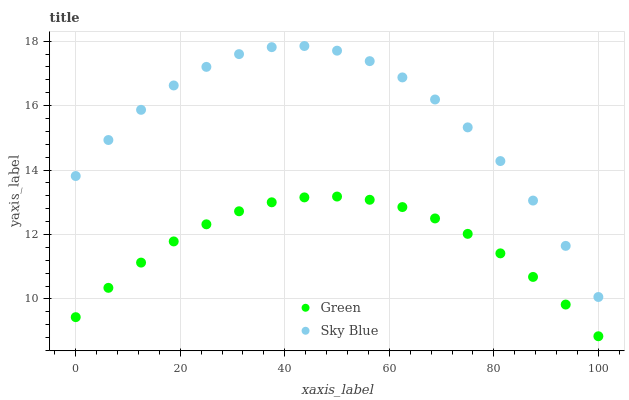Does Green have the minimum area under the curve?
Answer yes or no. Yes. Does Sky Blue have the maximum area under the curve?
Answer yes or no. Yes. Does Green have the maximum area under the curve?
Answer yes or no. No. Is Green the smoothest?
Answer yes or no. Yes. Is Sky Blue the roughest?
Answer yes or no. Yes. Is Green the roughest?
Answer yes or no. No. Does Green have the lowest value?
Answer yes or no. Yes. Does Sky Blue have the highest value?
Answer yes or no. Yes. Does Green have the highest value?
Answer yes or no. No. Is Green less than Sky Blue?
Answer yes or no. Yes. Is Sky Blue greater than Green?
Answer yes or no. Yes. Does Green intersect Sky Blue?
Answer yes or no. No. 